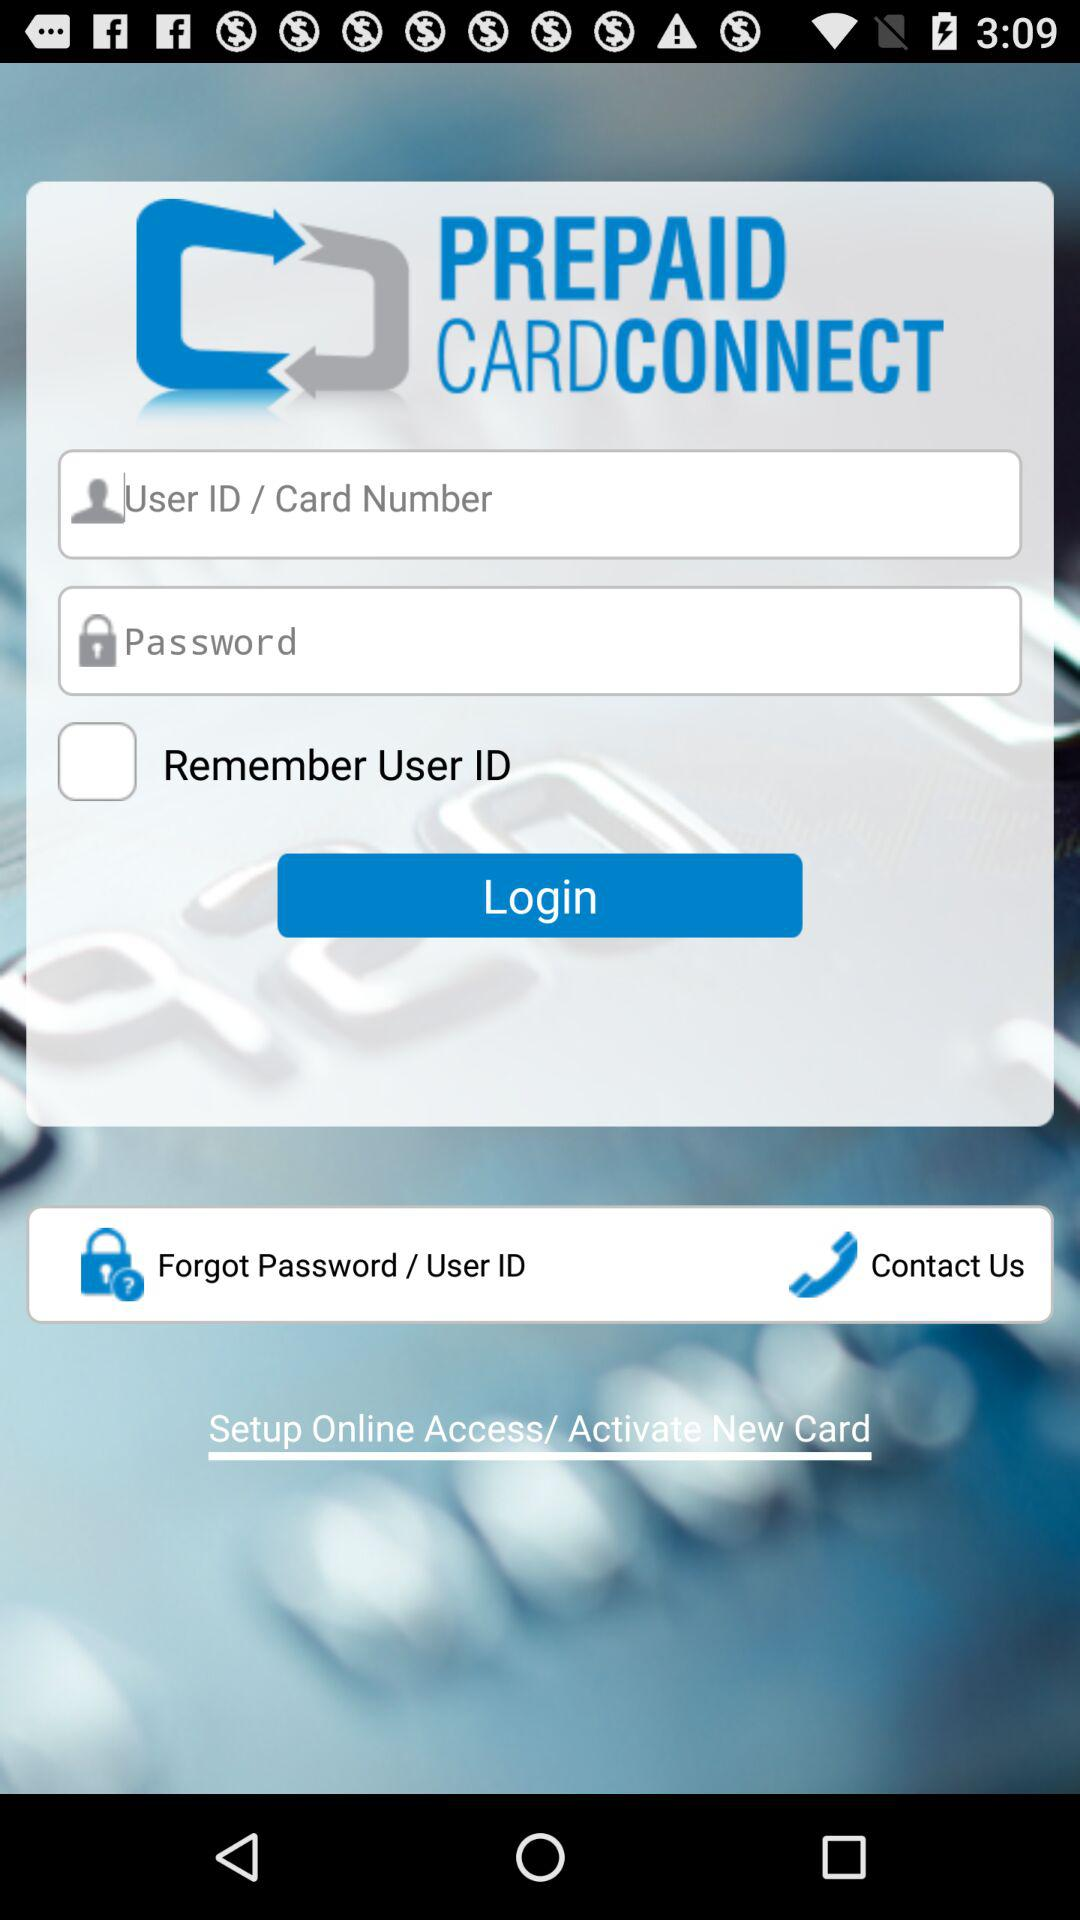What is the app name? The app name is "PREPAID CARDCONNECT". 